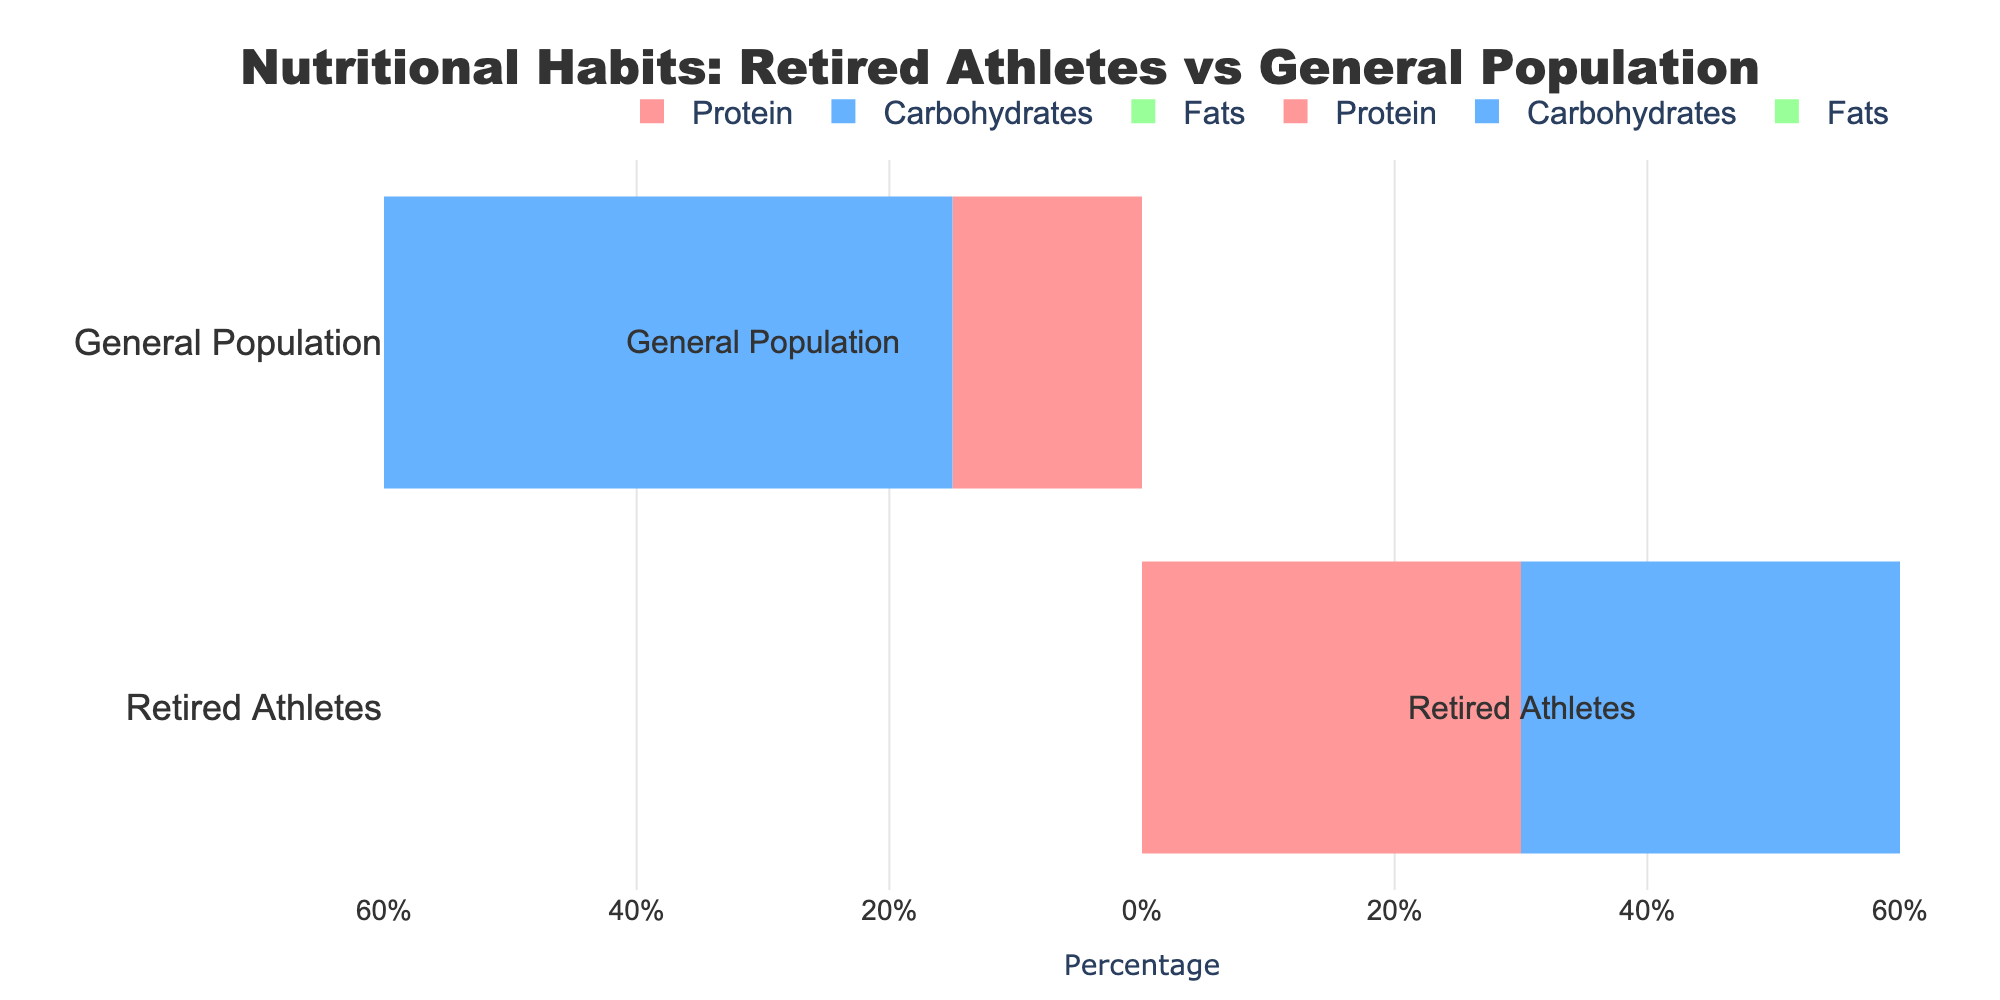what percentage of carbohydrates do retired athletes consume? The chart shows that retired athletes consume 40% of carbohydrates. The corresponding bar under "Retired Athletes" and labeled "Carbohydrates" extends to 40% on the x-axis.
Answer: 40% which group consumes a higher percentage of protein? Compare the length and direction of the bars labeled "Protein" for both groups. Retired Athletes have a longer positive bar (30%) whereas the General Population has a shorter negative bar (-15%). Therefore, retired athletes consume a higher percentage of protein.
Answer: Retired Athletes how do the fat consumption percentages compare between the two groups? Both groups show the same bar length and direction for fats, with the bar for fats equally extending to 30% for both groups. This means both groups consume an equal percentage of fats.
Answer: Equal calculate the average percentage of nutrients (protein, carbs, fats) for the retired athletes. Add the percentages of nutrients for retired athletes (30% + 40% + 30% = 100%) and then divide by the number of nutrients (3). The average is 100%/3 ≈ 33.3%.
Answer: 33.3% what is the difference in carbohydrate consumption between the retired athletes and the general population? Retired athletes consume 40% of carbohydrates, while the general population consumes 55%. The difference is calculated as 55% - 40% = 15%.
Answer: 15% which group has a more balanced diet in terms of the percentage of protein, carbs, and fats? To determine balance, compare the distribution percentages. Retired athletes have 30% protein, 40% carbs, and 30% fats which is relatively closer to each other, while the general population has 15% protein, 55% carbs, and 30% fats, showing a larger variance. Thus, retired athletes have a more balanced diet.
Answer: Retired Athletes how much more protein do retired athletes consume compared to the general population? Retired athletes consume 30% protein whereas the general population consumes 15% protein. The difference is calculated as 30% - 15% = 15%.
Answer: 15% what is the total percentage of carbohydrates and fats consumed by the general population? Add the percentages of carbohydrates and fats for the general population. Carbohydrates are 55% and fats are 30%, so the total is 55% + 30% = 85%.
Answer: 85% identify the nutrient with the largest difference in percentage intake between retired athletes and general population. Compare the percentage differences for each nutrient:
- Protein: 30% (Retired Athletes) - 15% (General Population) = 15%
- Carbohydrates: 40% (Retired Athletes) - 55% (General Population) = -15%
- Fats: 30% (Retired Athletes) - 30% (General Population) = 0%
The largest absolute difference is in carbohydrates with 15%.
Answer: Carbohydrates 